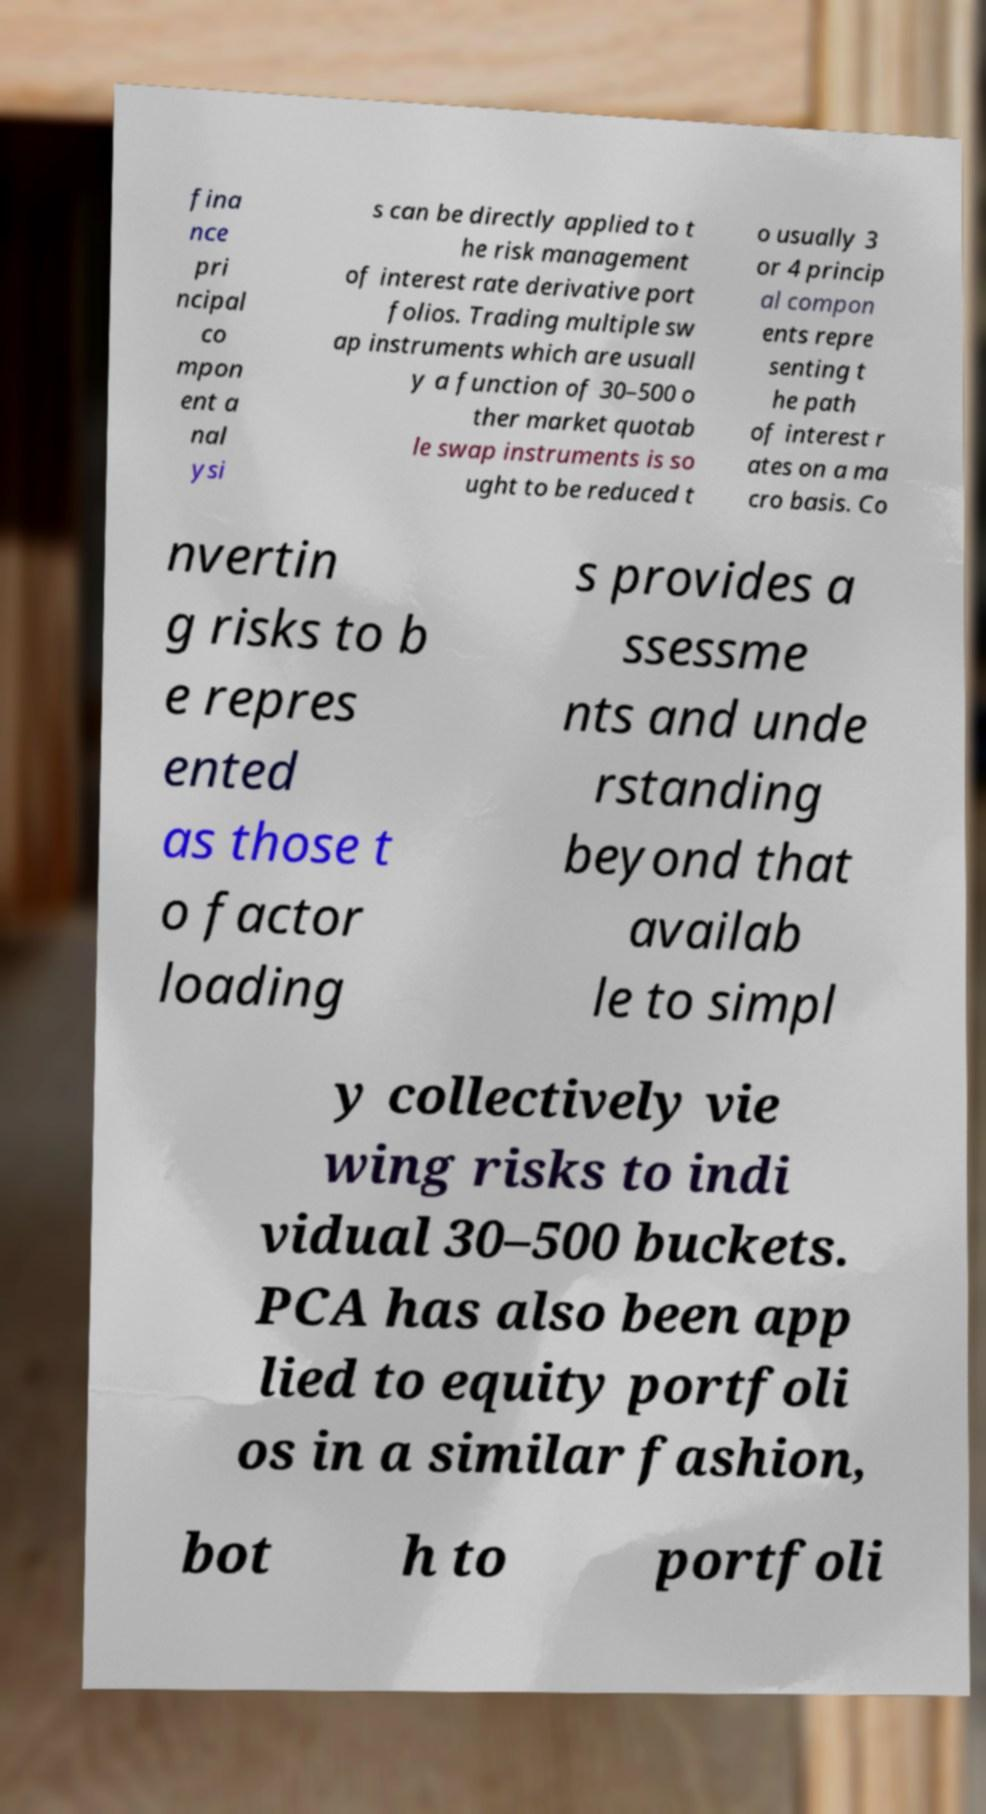Can you accurately transcribe the text from the provided image for me? fina nce pri ncipal co mpon ent a nal ysi s can be directly applied to t he risk management of interest rate derivative port folios. Trading multiple sw ap instruments which are usuall y a function of 30–500 o ther market quotab le swap instruments is so ught to be reduced t o usually 3 or 4 princip al compon ents repre senting t he path of interest r ates on a ma cro basis. Co nvertin g risks to b e repres ented as those t o factor loading s provides a ssessme nts and unde rstanding beyond that availab le to simpl y collectively vie wing risks to indi vidual 30–500 buckets. PCA has also been app lied to equity portfoli os in a similar fashion, bot h to portfoli 